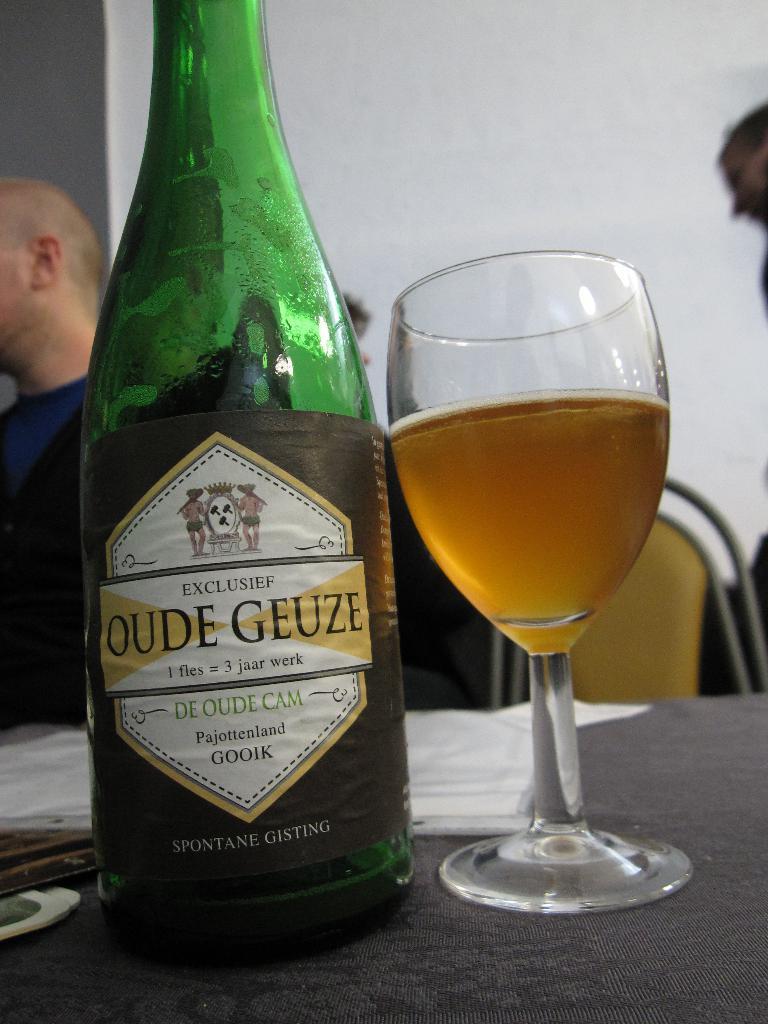Could you give a brief overview of what you see in this image? In this picture there is a bottle at the left side of the image and there is a glass at the right side of the image, glass contains drink in it and this two are placed on a table at the center of the image, there are people around the area of the image. 